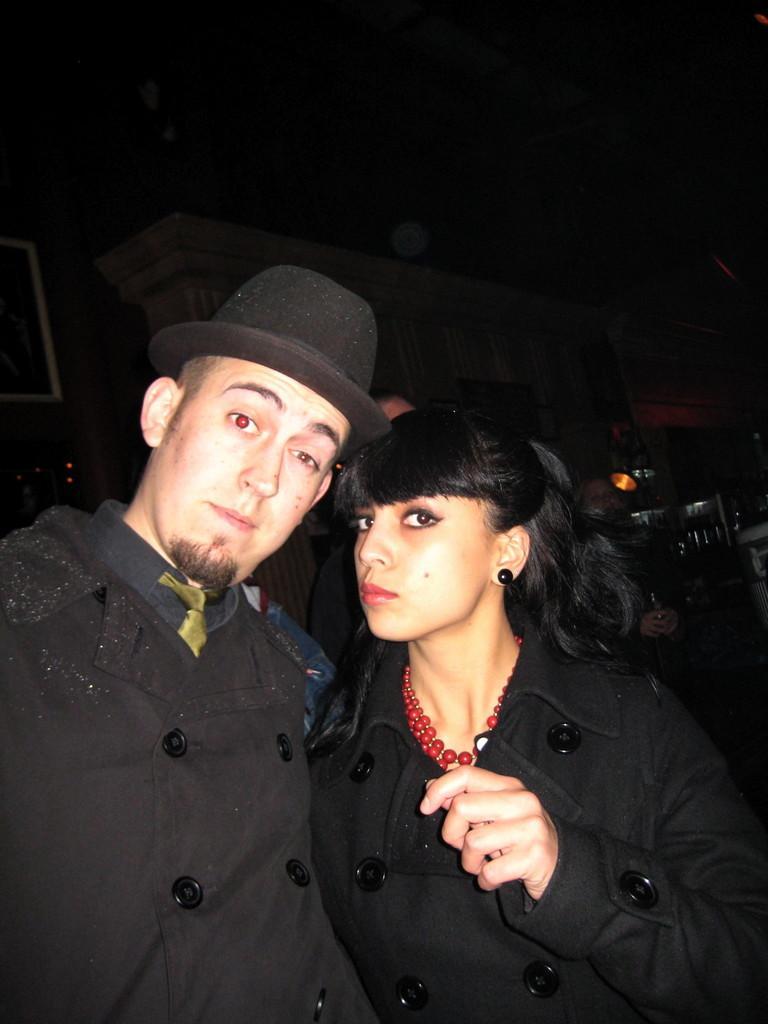Describe this image in one or two sentences. In this image we can see a man and a woman standing. In the background there are wall hangings attached to the wall, objects arranged in the cupboards and people standing on the floor. 